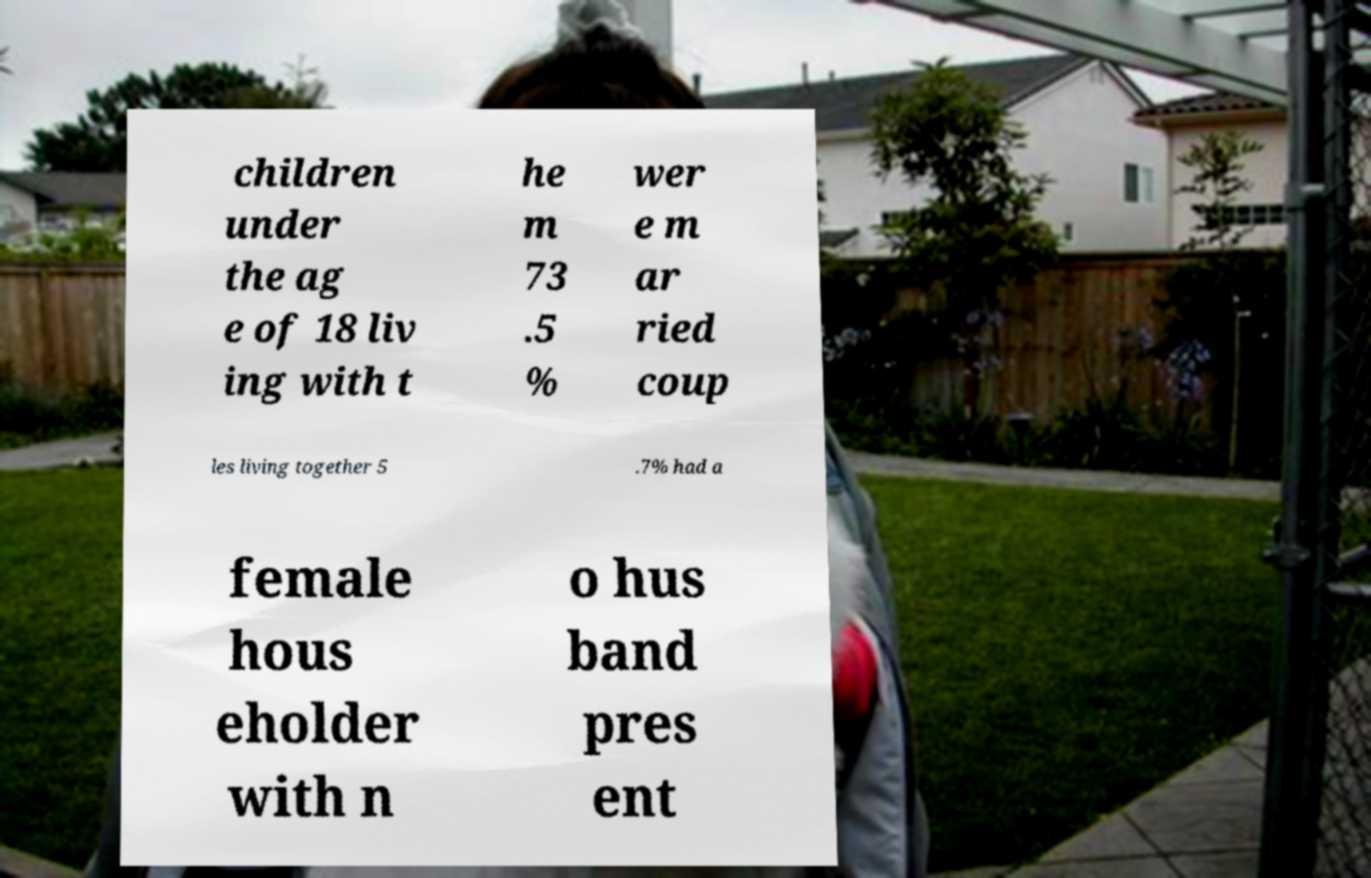Please identify and transcribe the text found in this image. children under the ag e of 18 liv ing with t he m 73 .5 % wer e m ar ried coup les living together 5 .7% had a female hous eholder with n o hus band pres ent 